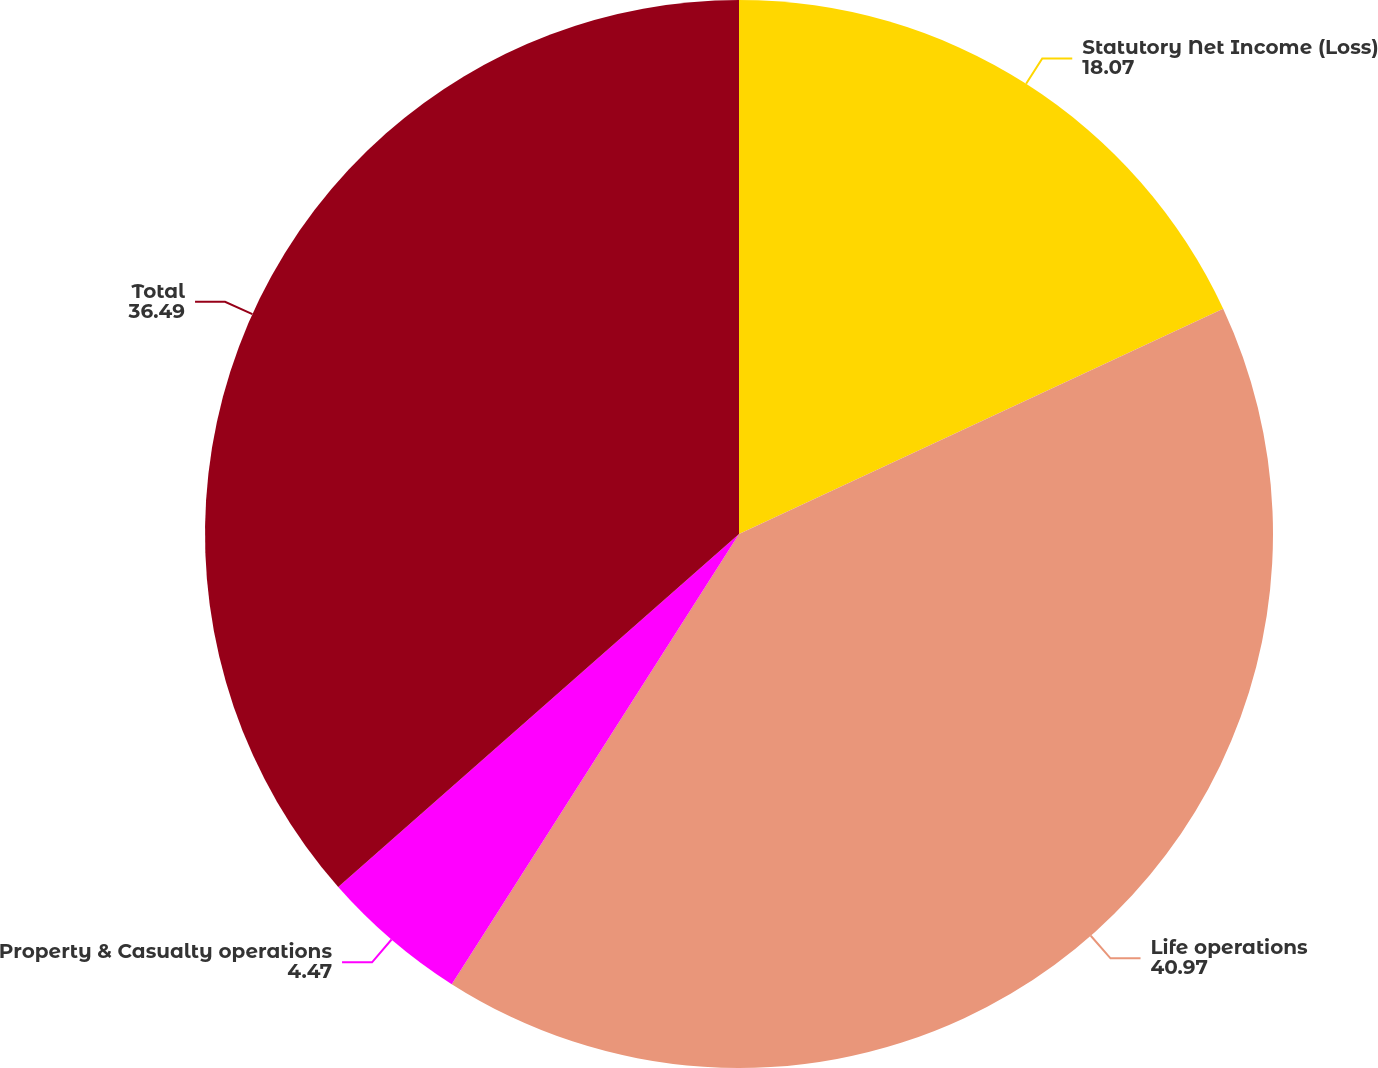Convert chart. <chart><loc_0><loc_0><loc_500><loc_500><pie_chart><fcel>Statutory Net Income (Loss)<fcel>Life operations<fcel>Property & Casualty operations<fcel>Total<nl><fcel>18.07%<fcel>40.97%<fcel>4.47%<fcel>36.49%<nl></chart> 